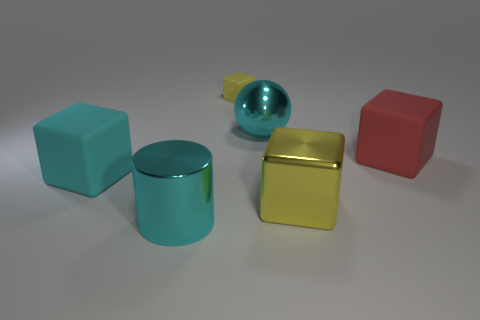There is a big metallic sphere; is its color the same as the matte thing on the left side of the cylinder?
Your response must be concise. Yes. Is the number of big metal things that are in front of the large metallic cylinder the same as the number of red blocks that are behind the shiny ball?
Make the answer very short. Yes. What is the material of the big cyan thing that is behind the large red matte thing?
Give a very brief answer. Metal. How many things are either big red matte blocks to the right of the small rubber thing or large yellow metallic objects?
Provide a short and direct response. 2. How many other objects are there of the same shape as the large red object?
Ensure brevity in your answer.  3. There is a cyan shiny thing that is left of the tiny rubber object; does it have the same shape as the small yellow object?
Your answer should be compact. No. There is a large cyan block; are there any large red matte cubes to the left of it?
Keep it short and to the point. No. How many big objects are either blue matte things or cyan metal objects?
Provide a succinct answer. 2. Does the sphere have the same material as the large cyan block?
Make the answer very short. No. The other cube that is the same color as the metallic block is what size?
Make the answer very short. Small. 